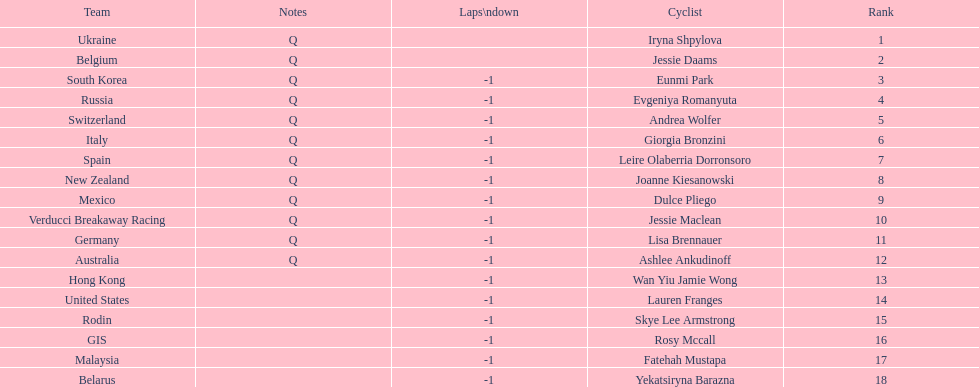How many cyclist do not have -1 laps down? 2. 